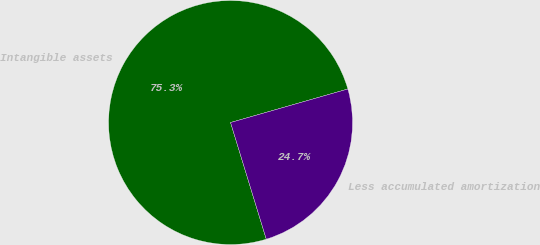Convert chart to OTSL. <chart><loc_0><loc_0><loc_500><loc_500><pie_chart><fcel>Intangible assets<fcel>Less accumulated amortization<nl><fcel>75.3%<fcel>24.7%<nl></chart> 